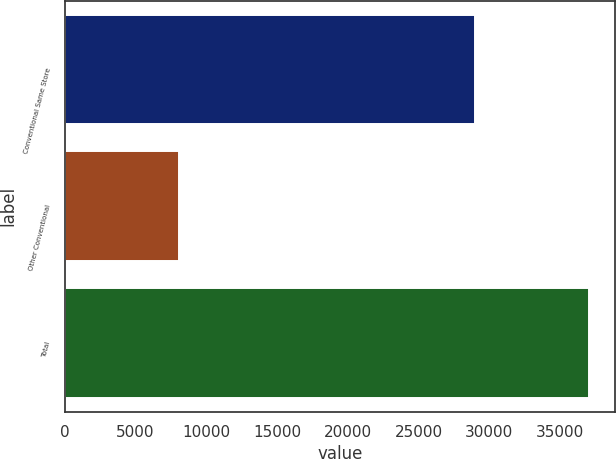Convert chart. <chart><loc_0><loc_0><loc_500><loc_500><bar_chart><fcel>Conventional Same Store<fcel>Other Conventional<fcel>Total<nl><fcel>28957<fcel>8053<fcel>37010<nl></chart> 